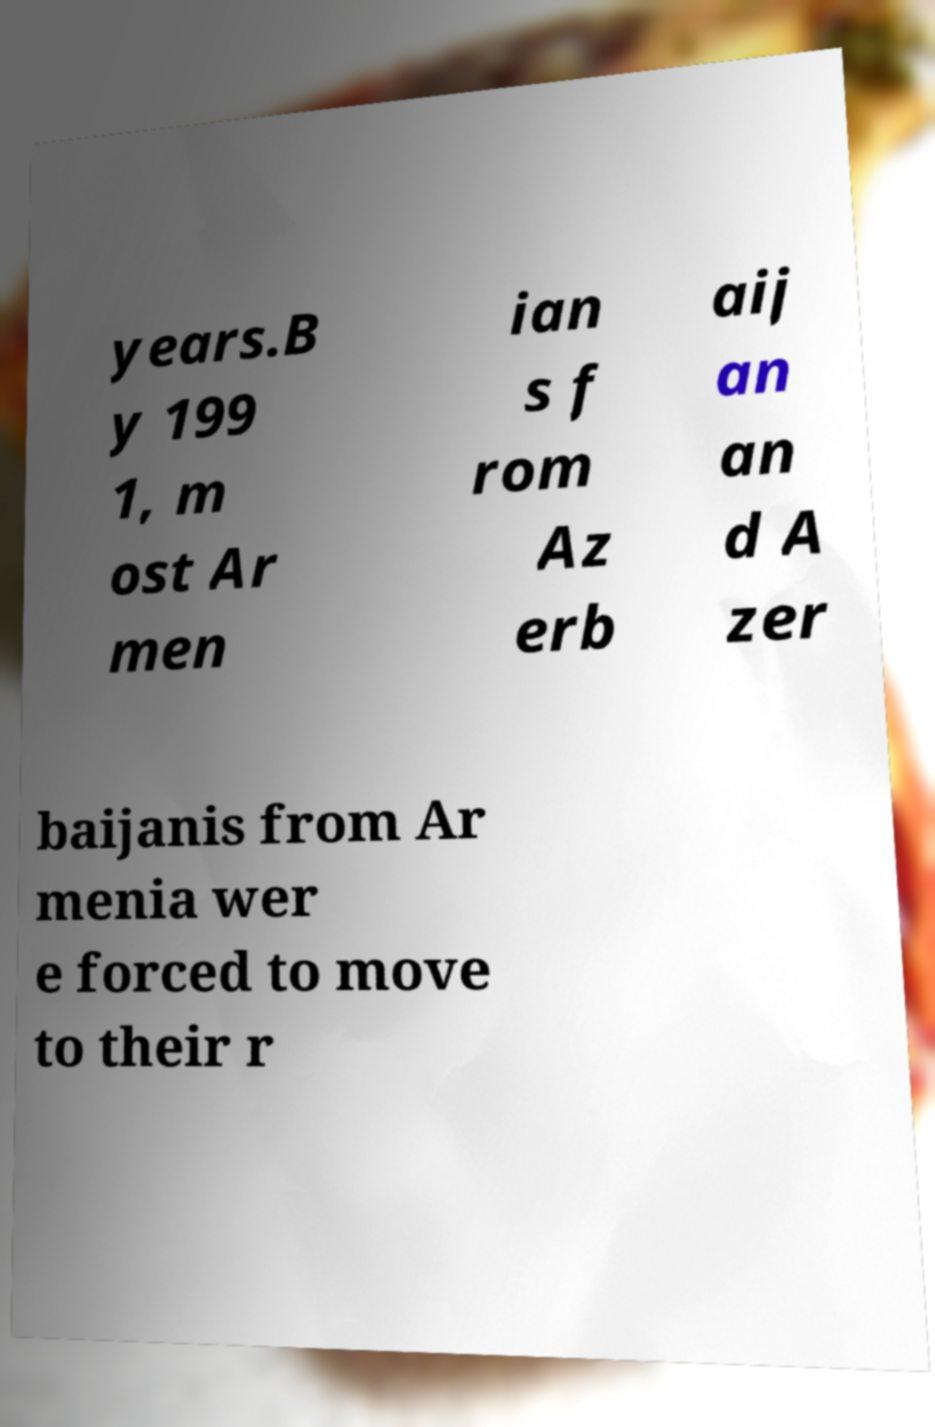Can you accurately transcribe the text from the provided image for me? years.B y 199 1, m ost Ar men ian s f rom Az erb aij an an d A zer baijanis from Ar menia wer e forced to move to their r 